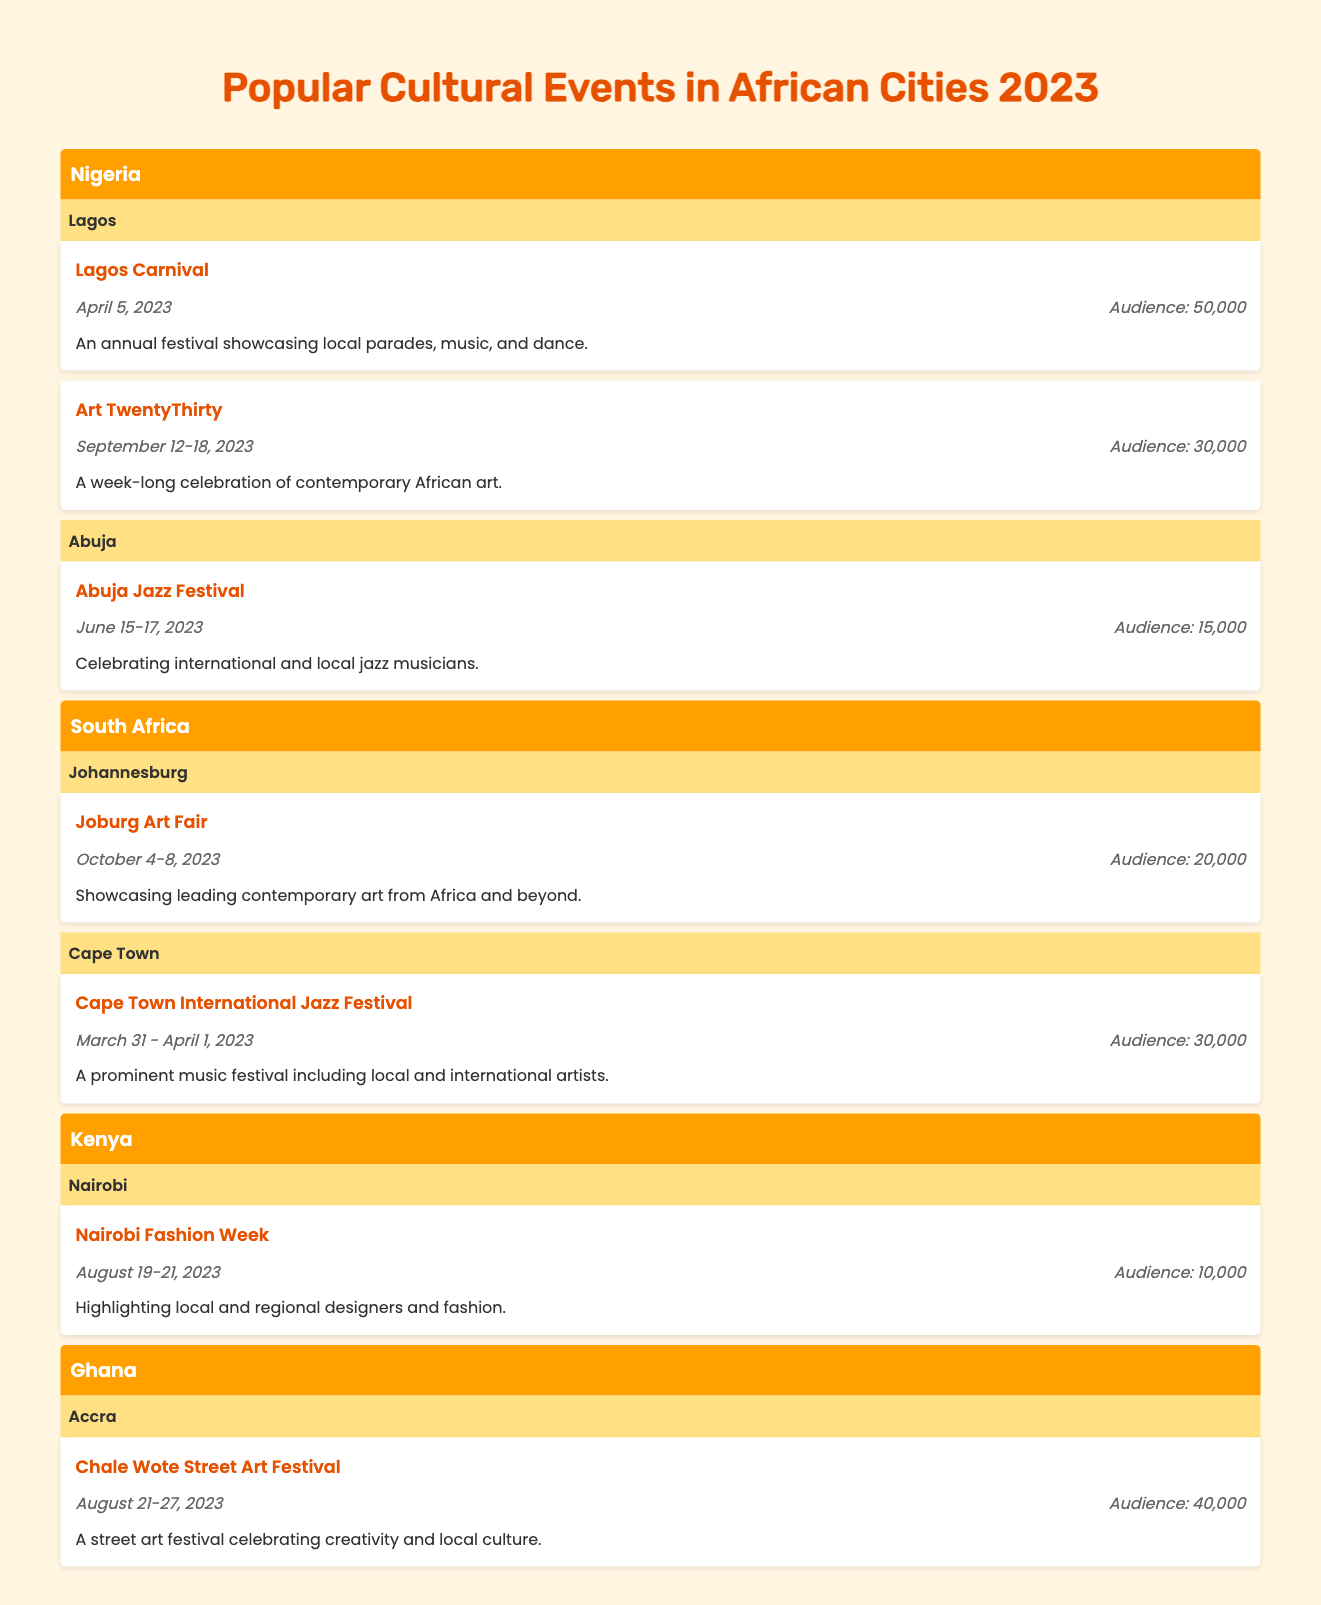What is the total audience for cultural events in Lagos? The total audience for cultural events in Lagos can be calculated by summing the audiences of the two events listed: Lagos Carnival (50,000) and Art TwentyThirty (30,000). Therefore, 50,000 + 30,000 = 80,000.
Answer: 80,000 How many events are there in Abuja? There is one cultural event in Abuja, which is the Abuja Jazz Festival.
Answer: 1 Which city has the highest attendance figure for an event and what is that figure? By comparing the audience figures of all the events listed, the Lagos Carnival has the highest attendance figure of 50,000.
Answer: 50,000 Is the Chale Wote Street Art Festival held in September? The Chale Wote Street Art Festival takes place from August 21-27, 2023, which is not in September. Thus, the answer is no.
Answer: No What is the combined audience for cultural events in South Africa? In South Africa, the audience figures are 20,000 for the Joburg Art Fair and 30,000 for the Cape Town International Jazz Festival. Summing these gives: 20,000 + 30,000 = 50,000.
Answer: 50,000 Which country hosted the event with the least attendance, and what was the event? The event with the least attendance is the Nairobi Fashion Week, which had an audience of 10,000, and it was hosted in Kenya.
Answer: Kenya; Nairobi Fashion Week Did any events have an audience of over 30,000? If so, how many? Yes, two events had audiences over 30,000: the Lagos Carnival (50,000) and the Cape Town International Jazz Festival (30,000), making a total of two events.
Answer: Yes, 2 What is the average audience across all events in Nigeria? In Nigeria, the events are Lagos Carnival (50,000), Art TwentyThirty (30,000), and Abuja Jazz Festival (15,000). First, sum them: 50,000 + 30,000 + 15,000 = 95,000. There are three events, so the average is 95,000 / 3 = approximately 31,667.
Answer: 31,667 Which festival celebrates local and regional designers in Nairobi? The festival that celebrates local and regional designers in Nairobi is the Nairobi Fashion Week.
Answer: Nairobi Fashion Week 